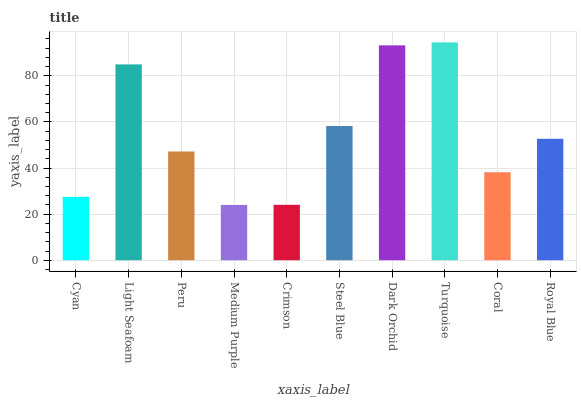Is Light Seafoam the minimum?
Answer yes or no. No. Is Light Seafoam the maximum?
Answer yes or no. No. Is Light Seafoam greater than Cyan?
Answer yes or no. Yes. Is Cyan less than Light Seafoam?
Answer yes or no. Yes. Is Cyan greater than Light Seafoam?
Answer yes or no. No. Is Light Seafoam less than Cyan?
Answer yes or no. No. Is Royal Blue the high median?
Answer yes or no. Yes. Is Peru the low median?
Answer yes or no. Yes. Is Medium Purple the high median?
Answer yes or no. No. Is Cyan the low median?
Answer yes or no. No. 